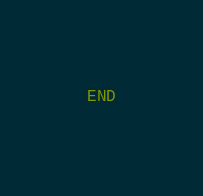<code> <loc_0><loc_0><loc_500><loc_500><_SQL_>END</code> 